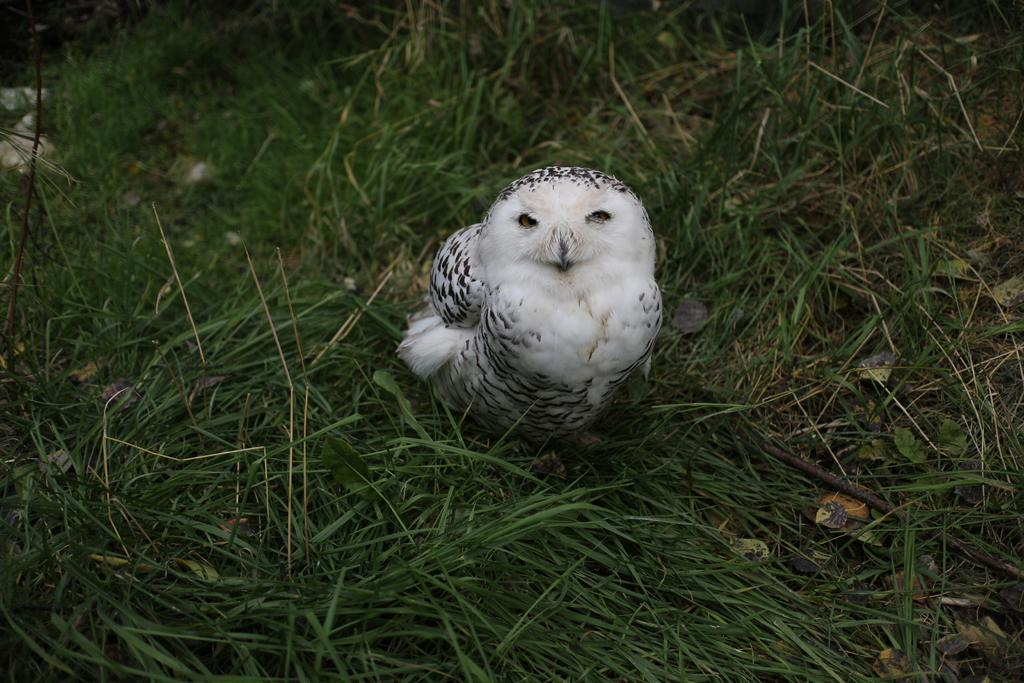What type of animal can be seen in the image? There is a bird in the image. Where is the bird located? The bird is on the grassland. What hobbies does the bird have in the image? There is no information about the bird's hobbies in the image. Is the bird a spy in the image? There is no indication in the image that the bird is a spy. 